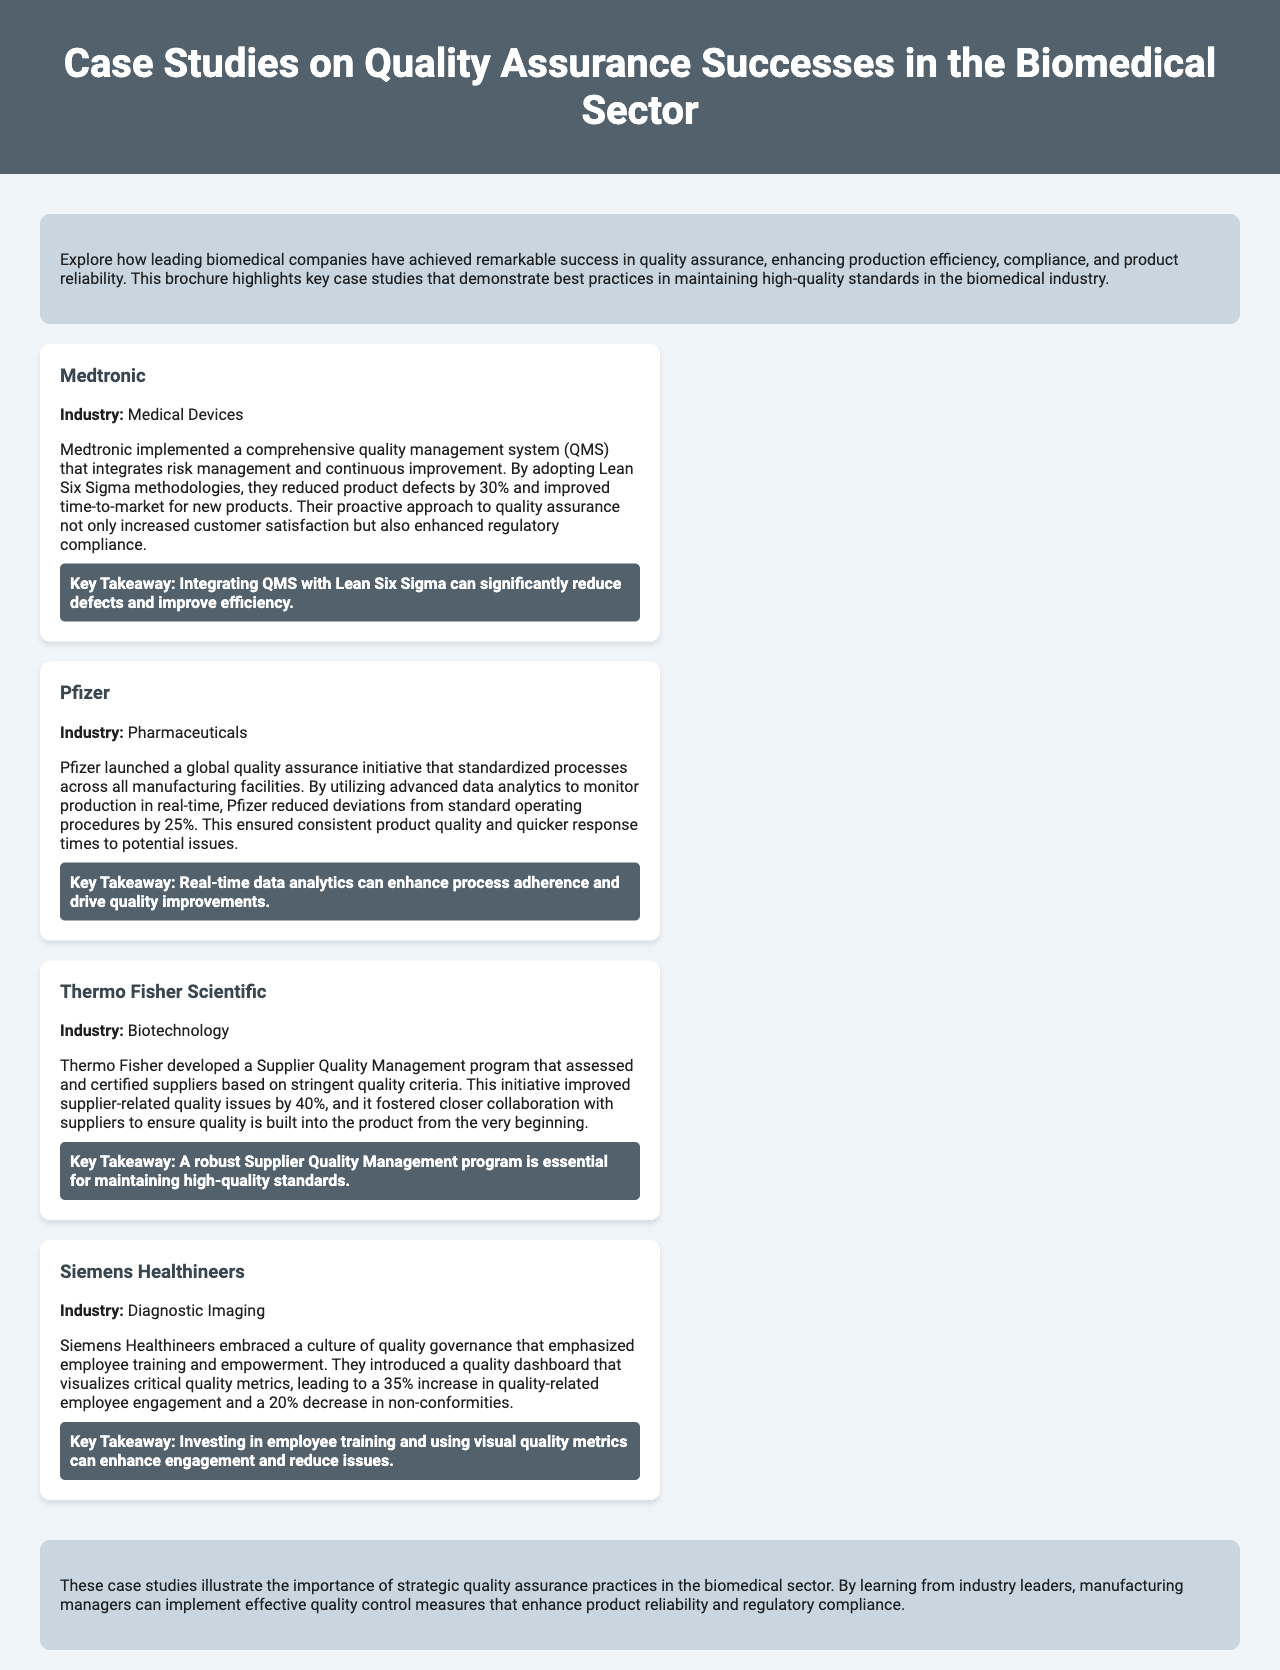What company implemented Lean Six Sigma? Medtronic is the company mentioned that implemented Lean Six Sigma methodologies to reduce defects.
Answer: Medtronic By what percentage did Medtronic reduce product defects? The document states that Medtronic reduced product defects by 30%.
Answer: 30% What global initiative did Pfizer launch? Pfizer launched a global quality assurance initiative that standardized processes.
Answer: Global quality assurance initiative What was the percentage decrease in deviations from standard operating procedures at Pfizer? Pfizer reduced deviations from standard operating procedures by 25%, as mentioned in the case study.
Answer: 25% What program did Thermo Fisher develop? Thermo Fisher developed a Supplier Quality Management program to certify suppliers based on quality criteria.
Answer: Supplier Quality Management program By what percentage did Thermo Fisher improve supplier-related quality issues? According to the document, Thermo Fisher improved supplier-related quality issues by 40%.
Answer: 40% What cultural emphasis did Siemens Healthineers adopt? Siemens Healthineers embraced a culture of quality governance that emphasized employee training.
Answer: Quality governance What increase in employee engagement did Siemens Healthineers report? Siemens Healthineers saw a 35% increase in quality-related employee engagement as noted in the document.
Answer: 35% What is a key takeaway from Medtronic's case study? The key takeaway from Medtronic's case study is that integrating QMS with Lean Six Sigma can significantly reduce defects.
Answer: Integrating QMS with Lean Six Sigma can significantly reduce defects 